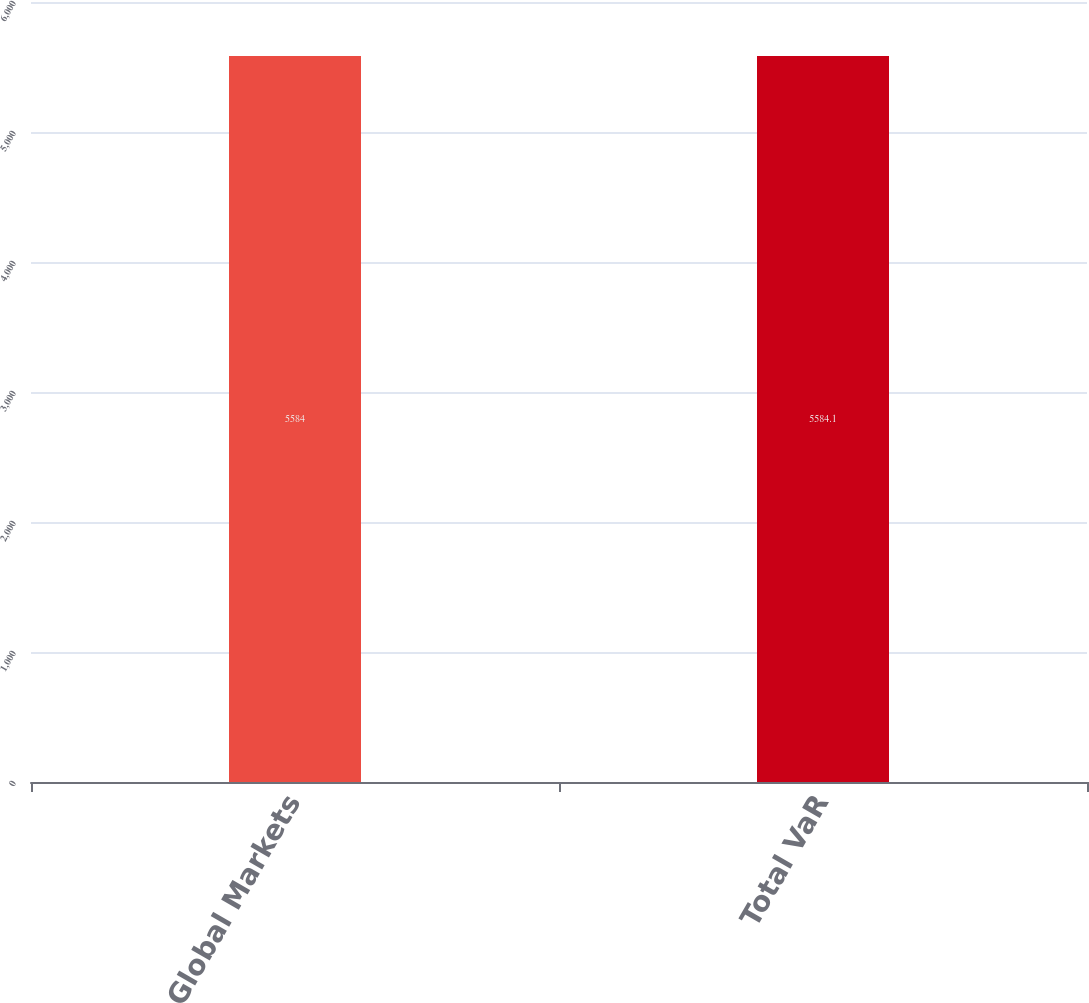<chart> <loc_0><loc_0><loc_500><loc_500><bar_chart><fcel>Global Markets<fcel>Total VaR<nl><fcel>5584<fcel>5584.1<nl></chart> 